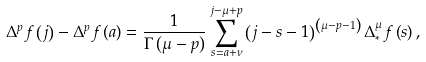<formula> <loc_0><loc_0><loc_500><loc_500>\Delta ^ { p } f \left ( j \right ) - \Delta ^ { p } f \left ( a \right ) = \frac { 1 } { \Gamma \left ( \mu - p \right ) } \sum _ { s = a + \nu } ^ { j - \mu + p } \left ( j - s - 1 \right ) ^ { \left ( \mu - p - 1 \right ) } \Delta _ { \ast } ^ { \mu } f \left ( s \right ) ,</formula> 